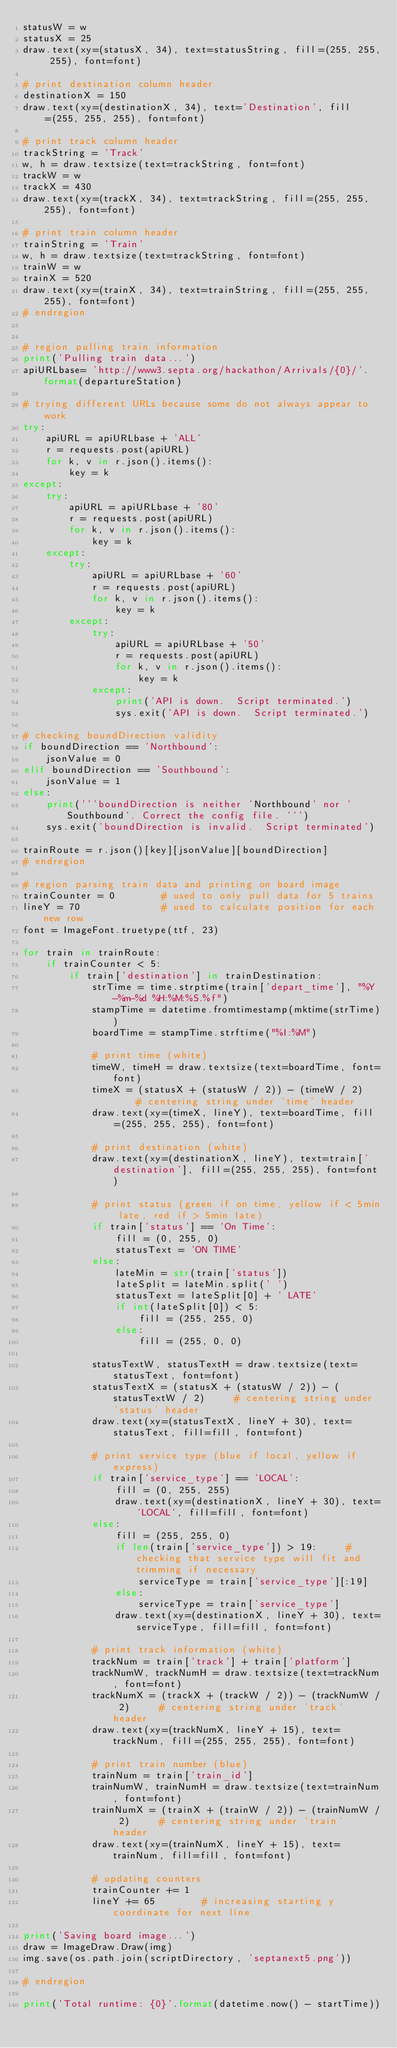Convert code to text. <code><loc_0><loc_0><loc_500><loc_500><_Python_>statusW = w
statusX = 25
draw.text(xy=(statusX, 34), text=statusString, fill=(255, 255, 255), font=font)

# print destination column header
destinationX = 150
draw.text(xy=(destinationX, 34), text='Destination', fill=(255, 255, 255), font=font)

# print track column header
trackString = 'Track'
w, h = draw.textsize(text=trackString, font=font)
trackW = w
trackX = 430
draw.text(xy=(trackX, 34), text=trackString, fill=(255, 255, 255), font=font)

# print train column header
trainString = 'Train'
w, h = draw.textsize(text=trackString, font=font)
trainW = w
trainX = 520
draw.text(xy=(trainX, 34), text=trainString, fill=(255, 255, 255), font=font)
# endregion


# region pulling train information
print('Pulling train data...')
apiURLbase= 'http://www3.septa.org/hackathon/Arrivals/{0}/'.format(departureStation)

# trying different URLs because some do not always appear to work
try:
    apiURL = apiURLbase + 'ALL'
    r = requests.post(apiURL)
    for k, v in r.json().items():
        key = k
except:
    try:
        apiURL = apiURLbase + '80'
        r = requests.post(apiURL)
        for k, v in r.json().items():
            key = k
    except:
        try:
            apiURL = apiURLbase + '60'
            r = requests.post(apiURL)
            for k, v in r.json().items():
                key = k
        except:
            try:
                apiURL = apiURLbase + '50'
                r = requests.post(apiURL)
                for k, v in r.json().items():
                    key = k
            except:
                print('API is down.  Script terminated.')
                sys.exit('API is down.  Script terminated.')

# checking boundDirection validity
if boundDirection == 'Northbound':
    jsonValue = 0
elif boundDirection == 'Southbound':
    jsonValue = 1
else:
    print('''boundDirection is neither 'Northbound' nor 'Southbound'. Correct the config file. ''')
    sys.exit('boundDirection is invalid.  Script terminated')

trainRoute = r.json()[key][jsonValue][boundDirection]
# endregion

# region parsing train data and printing on board image
trainCounter = 0        # used to only pull data for 5 trains
lineY = 70              # used to calculate position for each new row
font = ImageFont.truetype(ttf, 23)

for train in trainRoute:
    if trainCounter < 5:
        if train['destination'] in trainDestination:
            strTime = time.strptime(train['depart_time'], "%Y-%m-%d %H:%M:%S.%f")
            stampTime = datetime.fromtimestamp(mktime(strTime))
            boardTime = stampTime.strftime("%I:%M")

            # print time (white)
            timeW, timeH = draw.textsize(text=boardTime, font=font)
            timeX = (statusX + (statusW / 2)) - (timeW / 2)     # centering string under 'time' header
            draw.text(xy=(timeX, lineY), text=boardTime, fill=(255, 255, 255), font=font)

            # print destination (white)
            draw.text(xy=(destinationX, lineY), text=train['destination'], fill=(255, 255, 255), font=font)

            # print status (green if on time, yellow if < 5min late, red if > 5min late)
            if train['status'] == 'On Time':
                fill = (0, 255, 0)
                statusText = 'ON TIME'
            else:
                lateMin = str(train['status'])
                lateSplit = lateMin.split(' ')
                statusText = lateSplit[0] + ' LATE'
                if int(lateSplit[0]) < 5:
                    fill = (255, 255, 0)
                else:
                    fill = (255, 0, 0)

            statusTextW, statusTextH = draw.textsize(text=statusText, font=font)
            statusTextX = (statusX + (statusW / 2)) - (statusTextW / 2)     # centering string under 'status' header
            draw.text(xy=(statusTextX, lineY + 30), text=statusText, fill=fill, font=font)

            # print service type (blue if local, yellow if express)
            if train['service_type'] == 'LOCAL':
                fill = (0, 255, 255)
                draw.text(xy=(destinationX, lineY + 30), text='LOCAL', fill=fill, font=font)
            else:
                fill = (255, 255, 0)
                if len(train['service_type']) > 19:     # checking that service type will fit and trimming if necessary
                    serviceType = train['service_type'][:19]
                else:
                    serviceType = train['service_type']
                draw.text(xy=(destinationX, lineY + 30), text=serviceType, fill=fill, font=font)

            # print track information (white)
            trackNum = train['track'] + train['platform']
            trackNumW, trackNumH = draw.textsize(text=trackNum, font=font)
            trackNumX = (trackX + (trackW / 2)) - (trackNumW / 2)     # centering string under 'track' header
            draw.text(xy=(trackNumX, lineY + 15), text=trackNum, fill=(255, 255, 255), font=font)

            # print train number (blue)
            trainNum = train['train_id']
            trainNumW, trainNumH = draw.textsize(text=trainNum, font=font)
            trainNumX = (trainX + (trainW / 2)) - (trainNumW / 2)     # centering string under 'train' header
            draw.text(xy=(trainNumX, lineY + 15), text=trainNum, fill=fill, font=font)

            # updating counters
            trainCounter += 1
            lineY += 65        # increasing starting y coordinate for next line

print('Saving board image...')
draw = ImageDraw.Draw(img)
img.save(os.path.join(scriptDirectory, 'septanext5.png'))

# endregion

print('Total runtime: {0}'.format(datetime.now() - startTime))
</code> 